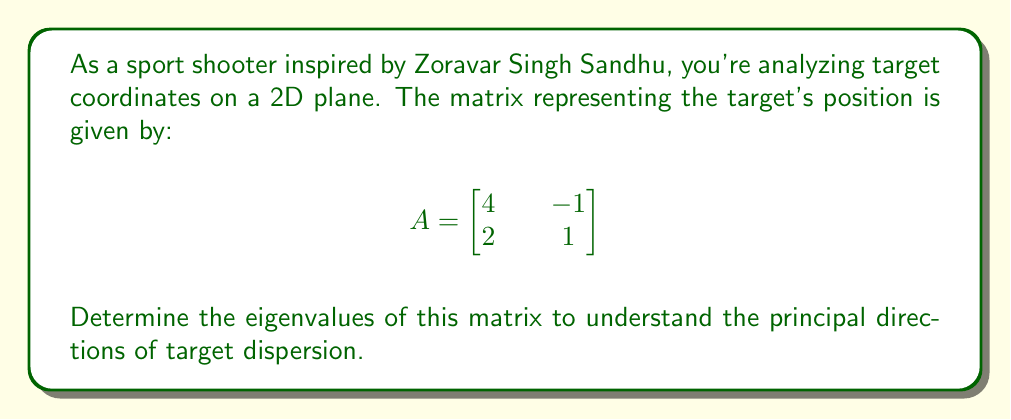What is the answer to this math problem? To find the eigenvalues of matrix A, we follow these steps:

1) The characteristic equation is given by $det(A - \lambda I) = 0$, where $\lambda$ represents the eigenvalues and $I$ is the 2x2 identity matrix.

2) Expand the determinant:
   $$det\begin{bmatrix}
   4-\lambda & -1 \\
   2 & 1-\lambda
   \end{bmatrix} = 0$$

3) Calculate the determinant:
   $$(4-\lambda)(1-\lambda) - (-1)(2) = 0$$

4) Simplify:
   $$4 - 4\lambda + \lambda^2 - \lambda + 2 = 0$$
   $$\lambda^2 - 5\lambda + 6 = 0$$

5) This is a quadratic equation. We can solve it using the quadratic formula:
   $$\lambda = \frac{-b \pm \sqrt{b^2 - 4ac}}{2a}$$
   
   Where $a=1$, $b=-5$, and $c=6$

6) Substituting these values:
   $$\lambda = \frac{5 \pm \sqrt{25 - 24}}{2} = \frac{5 \pm 1}{2}$$

7) Therefore, the eigenvalues are:
   $$\lambda_1 = \frac{5 + 1}{2} = 3$$
   $$\lambda_2 = \frac{5 - 1}{2} = 2$$
Answer: $\lambda_1 = 3$, $\lambda_2 = 2$ 